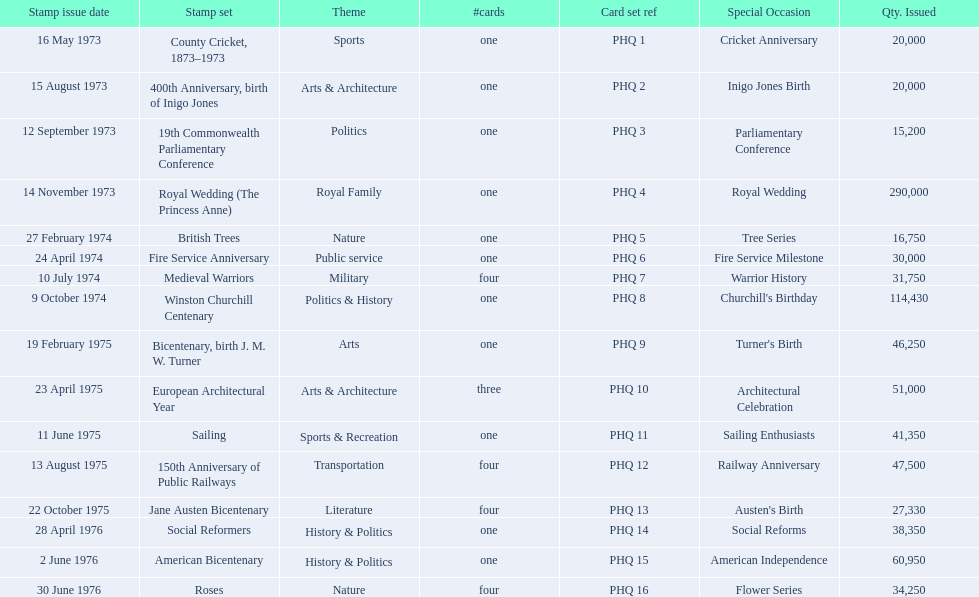Which stamp sets had three or more cards? Medieval Warriors, European Architectural Year, 150th Anniversary of Public Railways, Jane Austen Bicentenary, Roses. Of those, which one only has three cards? European Architectural Year. 